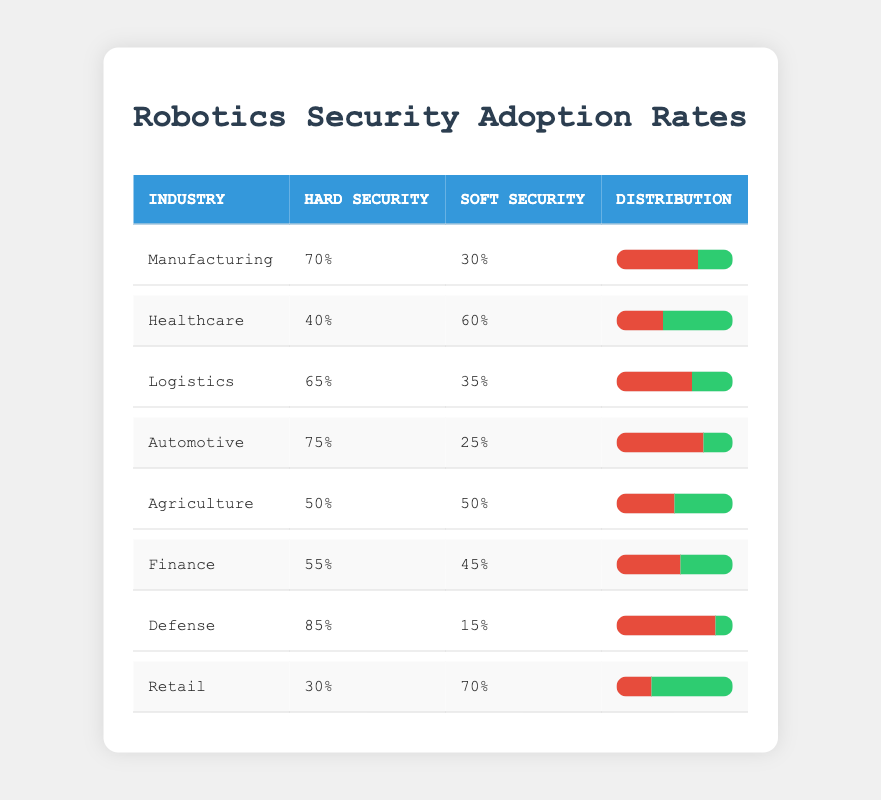What industry has the highest adoption rate of hard security measures? By examining the table, we see that the Defense industry has a hard security percentage of 85%, which is the highest compared to the other industries listed.
Answer: Defense What is the soft security adoption percentage for the Healthcare industry? The table indicates that the Healthcare industry has a soft security percentage of 60%.
Answer: 60% Which industry has a balanced adoption rate of hard and soft security measures? In the table, the Agriculture industry shows equal percentages for hard and soft security, both at 50%. This indicates a balanced adoption.
Answer: Agriculture What is the difference in adoption rates between hard and soft security measures in the Automotive industry? The Automotive industry has 75% for hard security and 25% for soft security. The difference is calculated as 75% - 25% = 50%.
Answer: 50% Is it true that the Logistics industry has a higher adoption rate of hard security measures than the Healthcare industry? The Logistics industry has a hard security percentage of 65%, while the Healthcare industry has 40%. Since 65% > 40%, the statement is true.
Answer: Yes What is the average adoption rate of hard security measures across all industries listed? To find the average, we sum the hard security percentages (70 + 40 + 65 + 75 + 50 + 55 + 85 + 30) = 570, and divide by the number of industries, which is 8. Therefore, the average is 570 / 8 = 71.25%.
Answer: 71.25% Which two industries have the lowest adoption rates of hard security measures? Looking at the table, the Retail industry has 30% and the Healthcare industry has 40% for hard security. They have the lowest percentages, respectively.
Answer: Retail, Healthcare What percentage of the Financial industry adopts soft security measures? The table shows that the Finance industry has a soft security adoption rate of 45%.
Answer: 45% What is the total percentage of soft security measures in the Manufacturing and Logistics industries combined? The Manufacturing industry has 30% soft security and the Logistics industry has 35%. Adding these gives us 30% + 35% = 65%.
Answer: 65% 